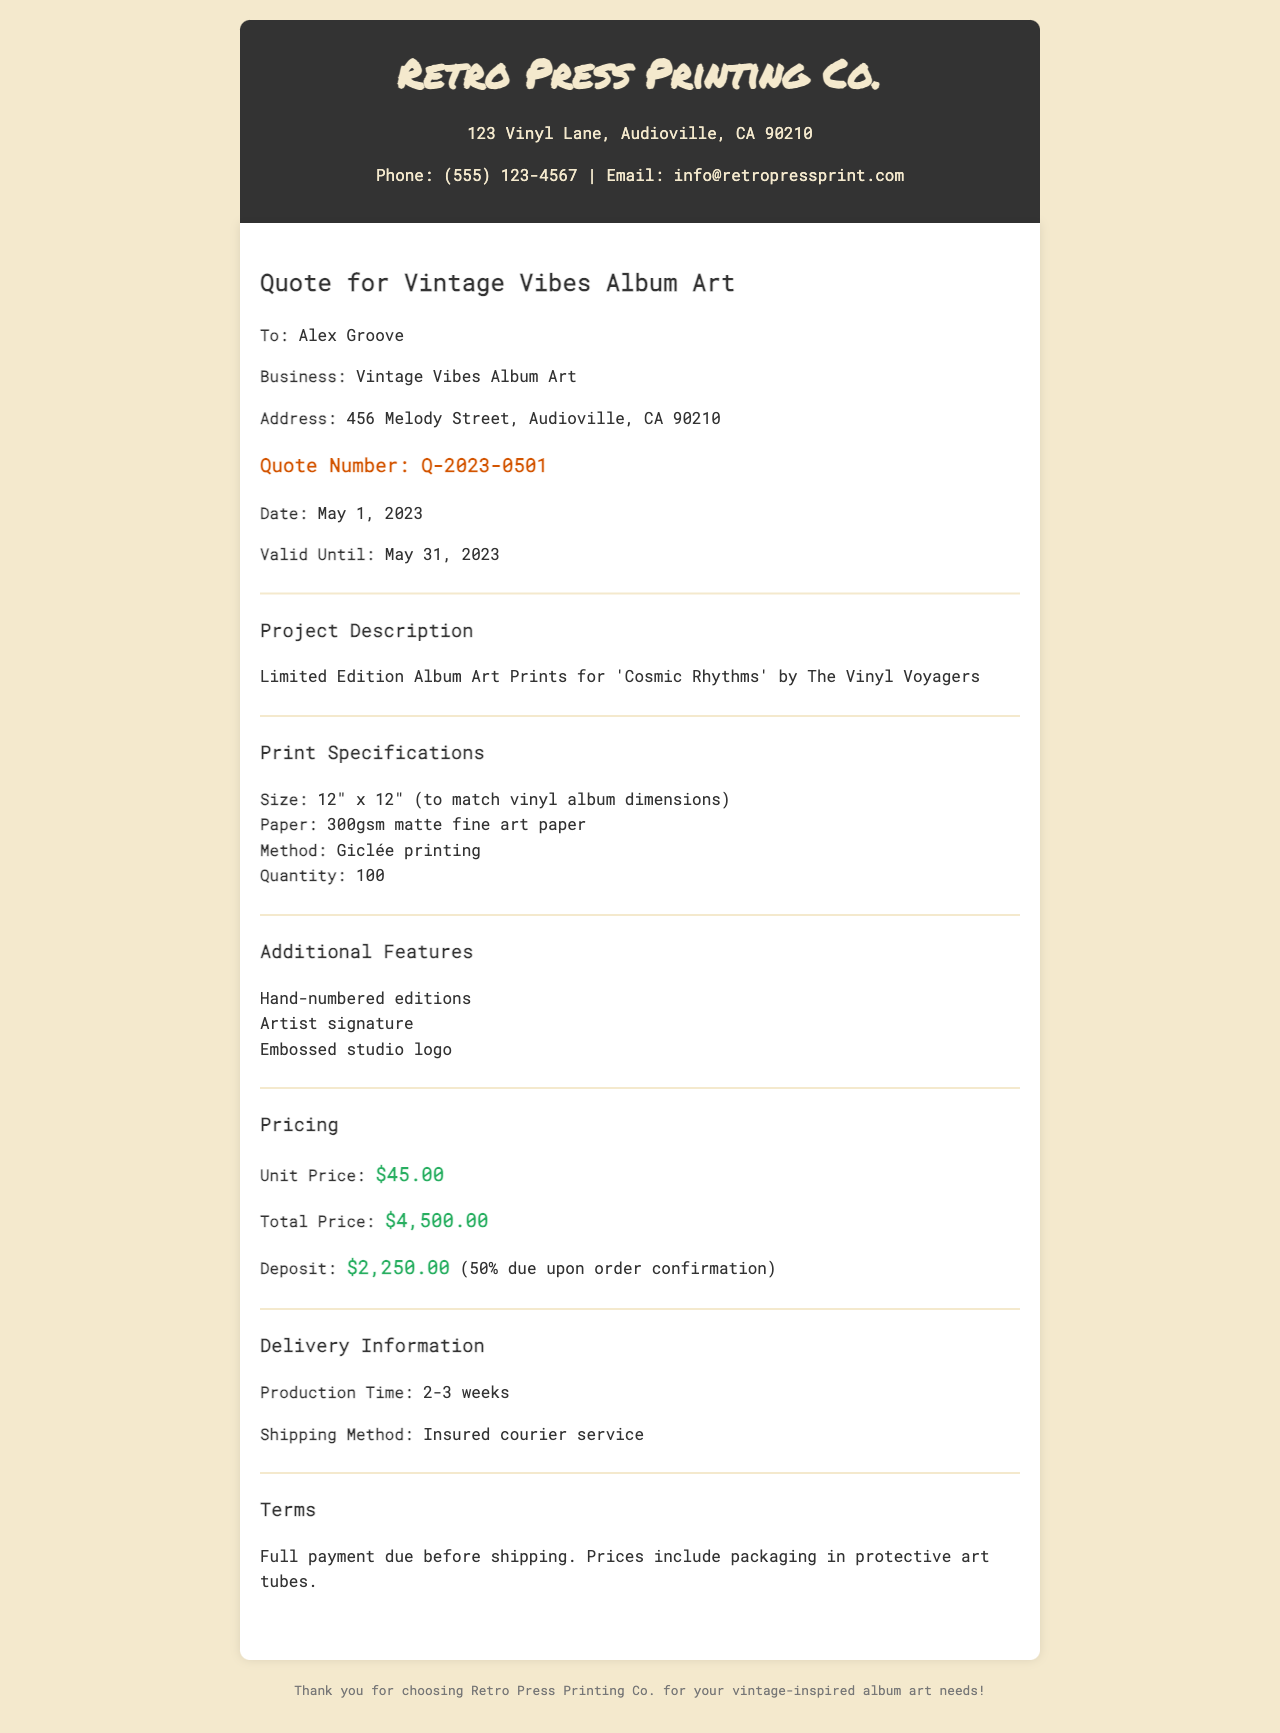What is the name of the printing company? The printing company is identified in the header section of the document.
Answer: Retro Press Printing Co What is the total price for the prints? The total price is specifically stated in the pricing section of the document.
Answer: $4,500.00 What is the quote number? The quote number is prominently mentioned in the document.
Answer: Q-2023-0501 Who is the quote addressed to? The recipient's name is indicated in the 'To:' section of the document.
Answer: Alex Groove What is the quantity of prints ordered? The quantity is specified in the print specifications section of the document.
Answer: 100 What is the unit price of each print? The unit price is clearly stated in the pricing section of the document.
Answer: $45.00 What is the production time for the prints? The production time is mentioned in the delivery information section.
Answer: 2-3 weeks What additional feature includes the artist's mark? This feature is detailed in the additional features section of the document.
Answer: Artist signature What is the required deposit amount? The deposit amount is specified in the pricing section of the document.
Answer: $2,250.00 